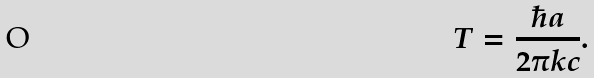Convert formula to latex. <formula><loc_0><loc_0><loc_500><loc_500>T = \frac { \hbar { a } } { 2 \pi k c } .</formula> 